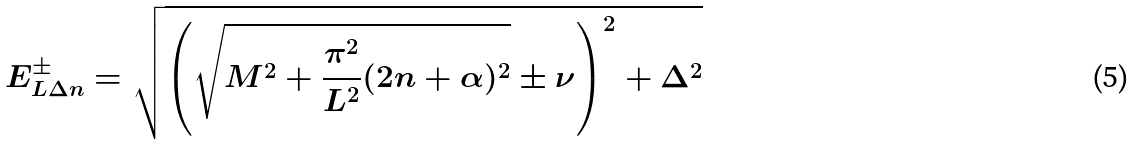<formula> <loc_0><loc_0><loc_500><loc_500>E _ { L \Delta n } ^ { \pm } = \sqrt { \left ( \sqrt { M ^ { 2 } + \frac { \pi ^ { 2 } } { L ^ { 2 } } ( 2 n + \alpha ) ^ { 2 } } \pm \nu \right ) ^ { 2 } + \Delta ^ { 2 } }</formula> 